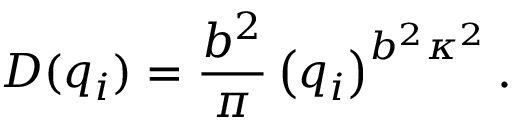Convert formula to latex. <formula><loc_0><loc_0><loc_500><loc_500>D ( q _ { i } ) = { \frac { b ^ { 2 } } { \pi } } \left ( q _ { i } \right ) ^ { b ^ { 2 } \kappa ^ { 2 } } .</formula> 